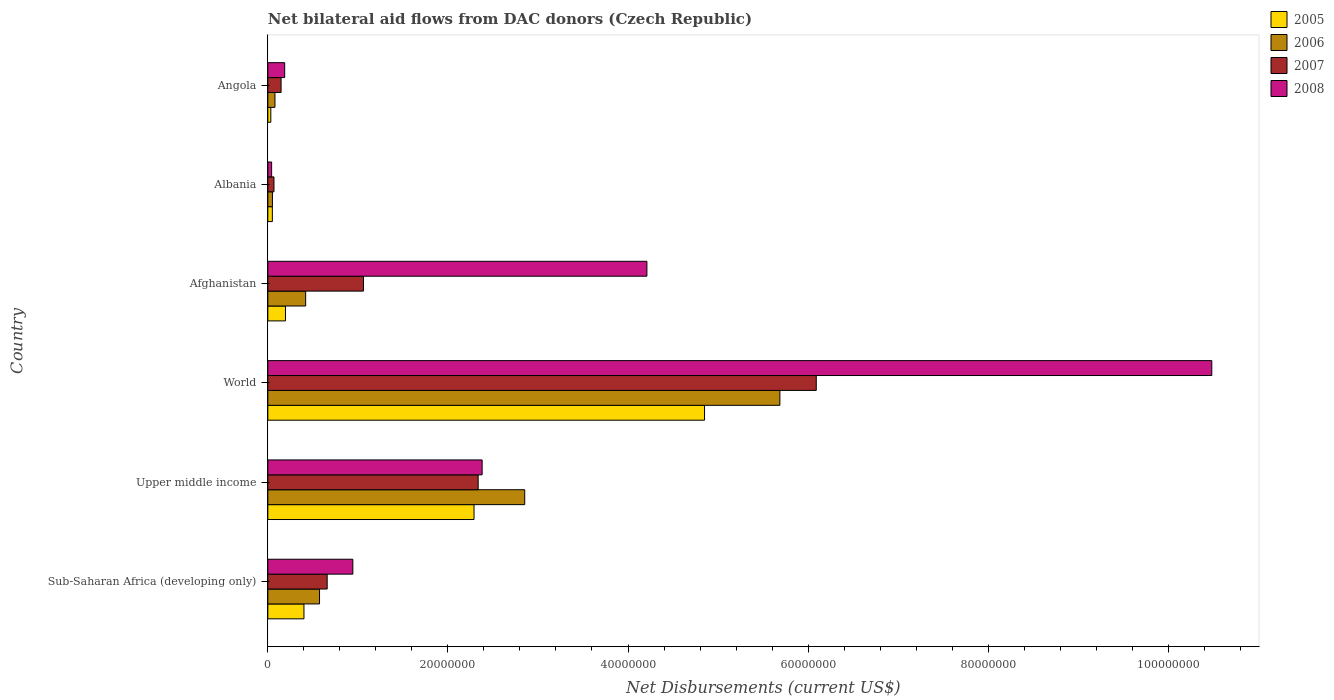How many groups of bars are there?
Ensure brevity in your answer.  6. Are the number of bars on each tick of the Y-axis equal?
Offer a very short reply. Yes. How many bars are there on the 2nd tick from the top?
Provide a short and direct response. 4. How many bars are there on the 3rd tick from the bottom?
Your answer should be very brief. 4. What is the label of the 5th group of bars from the top?
Offer a very short reply. Upper middle income. In how many cases, is the number of bars for a given country not equal to the number of legend labels?
Your answer should be very brief. 0. What is the net bilateral aid flows in 2007 in Upper middle income?
Your answer should be very brief. 2.34e+07. Across all countries, what is the maximum net bilateral aid flows in 2006?
Keep it short and to the point. 5.69e+07. In which country was the net bilateral aid flows in 2005 minimum?
Your response must be concise. Angola. What is the total net bilateral aid flows in 2005 in the graph?
Offer a very short reply. 7.82e+07. What is the difference between the net bilateral aid flows in 2005 in Afghanistan and that in World?
Give a very brief answer. -4.65e+07. What is the difference between the net bilateral aid flows in 2006 in Sub-Saharan Africa (developing only) and the net bilateral aid flows in 2008 in Upper middle income?
Provide a succinct answer. -1.81e+07. What is the average net bilateral aid flows in 2006 per country?
Provide a short and direct response. 1.61e+07. What is the difference between the net bilateral aid flows in 2005 and net bilateral aid flows in 2008 in World?
Ensure brevity in your answer.  -5.63e+07. What is the ratio of the net bilateral aid flows in 2007 in Sub-Saharan Africa (developing only) to that in World?
Keep it short and to the point. 0.11. What is the difference between the highest and the second highest net bilateral aid flows in 2007?
Your response must be concise. 3.76e+07. What is the difference between the highest and the lowest net bilateral aid flows in 2005?
Your answer should be compact. 4.82e+07. In how many countries, is the net bilateral aid flows in 2007 greater than the average net bilateral aid flows in 2007 taken over all countries?
Your response must be concise. 2. Is it the case that in every country, the sum of the net bilateral aid flows in 2008 and net bilateral aid flows in 2005 is greater than the net bilateral aid flows in 2006?
Provide a short and direct response. Yes. Does the graph contain any zero values?
Give a very brief answer. No. Does the graph contain grids?
Provide a succinct answer. No. Where does the legend appear in the graph?
Your response must be concise. Top right. What is the title of the graph?
Offer a very short reply. Net bilateral aid flows from DAC donors (Czech Republic). What is the label or title of the X-axis?
Your response must be concise. Net Disbursements (current US$). What is the Net Disbursements (current US$) in 2005 in Sub-Saharan Africa (developing only)?
Provide a succinct answer. 4.01e+06. What is the Net Disbursements (current US$) in 2006 in Sub-Saharan Africa (developing only)?
Give a very brief answer. 5.74e+06. What is the Net Disbursements (current US$) of 2007 in Sub-Saharan Africa (developing only)?
Your answer should be compact. 6.59e+06. What is the Net Disbursements (current US$) of 2008 in Sub-Saharan Africa (developing only)?
Make the answer very short. 9.44e+06. What is the Net Disbursements (current US$) of 2005 in Upper middle income?
Your answer should be compact. 2.29e+07. What is the Net Disbursements (current US$) in 2006 in Upper middle income?
Your response must be concise. 2.85e+07. What is the Net Disbursements (current US$) of 2007 in Upper middle income?
Make the answer very short. 2.34e+07. What is the Net Disbursements (current US$) in 2008 in Upper middle income?
Offer a very short reply. 2.38e+07. What is the Net Disbursements (current US$) in 2005 in World?
Keep it short and to the point. 4.85e+07. What is the Net Disbursements (current US$) in 2006 in World?
Keep it short and to the point. 5.69e+07. What is the Net Disbursements (current US$) of 2007 in World?
Offer a terse response. 6.09e+07. What is the Net Disbursements (current US$) of 2008 in World?
Offer a terse response. 1.05e+08. What is the Net Disbursements (current US$) in 2005 in Afghanistan?
Provide a short and direct response. 1.96e+06. What is the Net Disbursements (current US$) in 2006 in Afghanistan?
Keep it short and to the point. 4.20e+06. What is the Net Disbursements (current US$) in 2007 in Afghanistan?
Your response must be concise. 1.06e+07. What is the Net Disbursements (current US$) of 2008 in Afghanistan?
Offer a terse response. 4.21e+07. What is the Net Disbursements (current US$) of 2005 in Albania?
Your response must be concise. 5.00e+05. What is the Net Disbursements (current US$) of 2006 in Albania?
Offer a very short reply. 5.10e+05. What is the Net Disbursements (current US$) of 2007 in Albania?
Ensure brevity in your answer.  6.80e+05. What is the Net Disbursements (current US$) in 2008 in Albania?
Offer a very short reply. 4.20e+05. What is the Net Disbursements (current US$) of 2005 in Angola?
Make the answer very short. 3.30e+05. What is the Net Disbursements (current US$) of 2006 in Angola?
Your answer should be compact. 7.90e+05. What is the Net Disbursements (current US$) in 2007 in Angola?
Provide a short and direct response. 1.47e+06. What is the Net Disbursements (current US$) of 2008 in Angola?
Keep it short and to the point. 1.87e+06. Across all countries, what is the maximum Net Disbursements (current US$) in 2005?
Provide a succinct answer. 4.85e+07. Across all countries, what is the maximum Net Disbursements (current US$) of 2006?
Provide a succinct answer. 5.69e+07. Across all countries, what is the maximum Net Disbursements (current US$) of 2007?
Ensure brevity in your answer.  6.09e+07. Across all countries, what is the maximum Net Disbursements (current US$) of 2008?
Your answer should be compact. 1.05e+08. Across all countries, what is the minimum Net Disbursements (current US$) in 2006?
Provide a succinct answer. 5.10e+05. Across all countries, what is the minimum Net Disbursements (current US$) of 2007?
Your answer should be compact. 6.80e+05. What is the total Net Disbursements (current US$) in 2005 in the graph?
Provide a succinct answer. 7.82e+07. What is the total Net Disbursements (current US$) of 2006 in the graph?
Give a very brief answer. 9.66e+07. What is the total Net Disbursements (current US$) in 2007 in the graph?
Offer a terse response. 1.04e+08. What is the total Net Disbursements (current US$) of 2008 in the graph?
Give a very brief answer. 1.82e+08. What is the difference between the Net Disbursements (current US$) in 2005 in Sub-Saharan Africa (developing only) and that in Upper middle income?
Your answer should be compact. -1.89e+07. What is the difference between the Net Disbursements (current US$) of 2006 in Sub-Saharan Africa (developing only) and that in Upper middle income?
Offer a very short reply. -2.28e+07. What is the difference between the Net Disbursements (current US$) of 2007 in Sub-Saharan Africa (developing only) and that in Upper middle income?
Give a very brief answer. -1.68e+07. What is the difference between the Net Disbursements (current US$) of 2008 in Sub-Saharan Africa (developing only) and that in Upper middle income?
Give a very brief answer. -1.44e+07. What is the difference between the Net Disbursements (current US$) in 2005 in Sub-Saharan Africa (developing only) and that in World?
Your answer should be very brief. -4.45e+07. What is the difference between the Net Disbursements (current US$) in 2006 in Sub-Saharan Africa (developing only) and that in World?
Give a very brief answer. -5.11e+07. What is the difference between the Net Disbursements (current US$) in 2007 in Sub-Saharan Africa (developing only) and that in World?
Your answer should be compact. -5.43e+07. What is the difference between the Net Disbursements (current US$) of 2008 in Sub-Saharan Africa (developing only) and that in World?
Your answer should be very brief. -9.54e+07. What is the difference between the Net Disbursements (current US$) of 2005 in Sub-Saharan Africa (developing only) and that in Afghanistan?
Provide a short and direct response. 2.05e+06. What is the difference between the Net Disbursements (current US$) in 2006 in Sub-Saharan Africa (developing only) and that in Afghanistan?
Provide a short and direct response. 1.54e+06. What is the difference between the Net Disbursements (current US$) of 2007 in Sub-Saharan Africa (developing only) and that in Afghanistan?
Provide a short and direct response. -4.03e+06. What is the difference between the Net Disbursements (current US$) of 2008 in Sub-Saharan Africa (developing only) and that in Afghanistan?
Your answer should be very brief. -3.27e+07. What is the difference between the Net Disbursements (current US$) of 2005 in Sub-Saharan Africa (developing only) and that in Albania?
Keep it short and to the point. 3.51e+06. What is the difference between the Net Disbursements (current US$) in 2006 in Sub-Saharan Africa (developing only) and that in Albania?
Provide a short and direct response. 5.23e+06. What is the difference between the Net Disbursements (current US$) of 2007 in Sub-Saharan Africa (developing only) and that in Albania?
Provide a succinct answer. 5.91e+06. What is the difference between the Net Disbursements (current US$) of 2008 in Sub-Saharan Africa (developing only) and that in Albania?
Keep it short and to the point. 9.02e+06. What is the difference between the Net Disbursements (current US$) of 2005 in Sub-Saharan Africa (developing only) and that in Angola?
Your answer should be very brief. 3.68e+06. What is the difference between the Net Disbursements (current US$) of 2006 in Sub-Saharan Africa (developing only) and that in Angola?
Give a very brief answer. 4.95e+06. What is the difference between the Net Disbursements (current US$) in 2007 in Sub-Saharan Africa (developing only) and that in Angola?
Your answer should be very brief. 5.12e+06. What is the difference between the Net Disbursements (current US$) in 2008 in Sub-Saharan Africa (developing only) and that in Angola?
Your answer should be very brief. 7.57e+06. What is the difference between the Net Disbursements (current US$) in 2005 in Upper middle income and that in World?
Provide a succinct answer. -2.56e+07. What is the difference between the Net Disbursements (current US$) of 2006 in Upper middle income and that in World?
Your answer should be compact. -2.83e+07. What is the difference between the Net Disbursements (current US$) of 2007 in Upper middle income and that in World?
Provide a succinct answer. -3.76e+07. What is the difference between the Net Disbursements (current US$) in 2008 in Upper middle income and that in World?
Offer a terse response. -8.10e+07. What is the difference between the Net Disbursements (current US$) of 2005 in Upper middle income and that in Afghanistan?
Ensure brevity in your answer.  2.09e+07. What is the difference between the Net Disbursements (current US$) of 2006 in Upper middle income and that in Afghanistan?
Your answer should be very brief. 2.43e+07. What is the difference between the Net Disbursements (current US$) of 2007 in Upper middle income and that in Afghanistan?
Offer a terse response. 1.27e+07. What is the difference between the Net Disbursements (current US$) of 2008 in Upper middle income and that in Afghanistan?
Provide a short and direct response. -1.83e+07. What is the difference between the Net Disbursements (current US$) in 2005 in Upper middle income and that in Albania?
Make the answer very short. 2.24e+07. What is the difference between the Net Disbursements (current US$) of 2006 in Upper middle income and that in Albania?
Give a very brief answer. 2.80e+07. What is the difference between the Net Disbursements (current US$) in 2007 in Upper middle income and that in Albania?
Offer a very short reply. 2.27e+07. What is the difference between the Net Disbursements (current US$) in 2008 in Upper middle income and that in Albania?
Provide a succinct answer. 2.34e+07. What is the difference between the Net Disbursements (current US$) of 2005 in Upper middle income and that in Angola?
Your response must be concise. 2.26e+07. What is the difference between the Net Disbursements (current US$) of 2006 in Upper middle income and that in Angola?
Keep it short and to the point. 2.77e+07. What is the difference between the Net Disbursements (current US$) of 2007 in Upper middle income and that in Angola?
Give a very brief answer. 2.19e+07. What is the difference between the Net Disbursements (current US$) in 2008 in Upper middle income and that in Angola?
Provide a short and direct response. 2.19e+07. What is the difference between the Net Disbursements (current US$) in 2005 in World and that in Afghanistan?
Your answer should be very brief. 4.65e+07. What is the difference between the Net Disbursements (current US$) of 2006 in World and that in Afghanistan?
Provide a succinct answer. 5.27e+07. What is the difference between the Net Disbursements (current US$) in 2007 in World and that in Afghanistan?
Provide a succinct answer. 5.03e+07. What is the difference between the Net Disbursements (current US$) in 2008 in World and that in Afghanistan?
Provide a short and direct response. 6.27e+07. What is the difference between the Net Disbursements (current US$) in 2005 in World and that in Albania?
Keep it short and to the point. 4.80e+07. What is the difference between the Net Disbursements (current US$) in 2006 in World and that in Albania?
Your answer should be compact. 5.64e+07. What is the difference between the Net Disbursements (current US$) in 2007 in World and that in Albania?
Keep it short and to the point. 6.02e+07. What is the difference between the Net Disbursements (current US$) of 2008 in World and that in Albania?
Your answer should be very brief. 1.04e+08. What is the difference between the Net Disbursements (current US$) of 2005 in World and that in Angola?
Your answer should be very brief. 4.82e+07. What is the difference between the Net Disbursements (current US$) of 2006 in World and that in Angola?
Ensure brevity in your answer.  5.61e+07. What is the difference between the Net Disbursements (current US$) of 2007 in World and that in Angola?
Make the answer very short. 5.94e+07. What is the difference between the Net Disbursements (current US$) of 2008 in World and that in Angola?
Give a very brief answer. 1.03e+08. What is the difference between the Net Disbursements (current US$) in 2005 in Afghanistan and that in Albania?
Your answer should be very brief. 1.46e+06. What is the difference between the Net Disbursements (current US$) of 2006 in Afghanistan and that in Albania?
Offer a very short reply. 3.69e+06. What is the difference between the Net Disbursements (current US$) in 2007 in Afghanistan and that in Albania?
Keep it short and to the point. 9.94e+06. What is the difference between the Net Disbursements (current US$) of 2008 in Afghanistan and that in Albania?
Offer a terse response. 4.17e+07. What is the difference between the Net Disbursements (current US$) of 2005 in Afghanistan and that in Angola?
Your answer should be very brief. 1.63e+06. What is the difference between the Net Disbursements (current US$) in 2006 in Afghanistan and that in Angola?
Offer a terse response. 3.41e+06. What is the difference between the Net Disbursements (current US$) of 2007 in Afghanistan and that in Angola?
Provide a short and direct response. 9.15e+06. What is the difference between the Net Disbursements (current US$) of 2008 in Afghanistan and that in Angola?
Ensure brevity in your answer.  4.02e+07. What is the difference between the Net Disbursements (current US$) in 2006 in Albania and that in Angola?
Provide a short and direct response. -2.80e+05. What is the difference between the Net Disbursements (current US$) in 2007 in Albania and that in Angola?
Provide a succinct answer. -7.90e+05. What is the difference between the Net Disbursements (current US$) of 2008 in Albania and that in Angola?
Your answer should be very brief. -1.45e+06. What is the difference between the Net Disbursements (current US$) in 2005 in Sub-Saharan Africa (developing only) and the Net Disbursements (current US$) in 2006 in Upper middle income?
Give a very brief answer. -2.45e+07. What is the difference between the Net Disbursements (current US$) of 2005 in Sub-Saharan Africa (developing only) and the Net Disbursements (current US$) of 2007 in Upper middle income?
Provide a succinct answer. -1.94e+07. What is the difference between the Net Disbursements (current US$) in 2005 in Sub-Saharan Africa (developing only) and the Net Disbursements (current US$) in 2008 in Upper middle income?
Your response must be concise. -1.98e+07. What is the difference between the Net Disbursements (current US$) of 2006 in Sub-Saharan Africa (developing only) and the Net Disbursements (current US$) of 2007 in Upper middle income?
Provide a succinct answer. -1.76e+07. What is the difference between the Net Disbursements (current US$) of 2006 in Sub-Saharan Africa (developing only) and the Net Disbursements (current US$) of 2008 in Upper middle income?
Your answer should be very brief. -1.81e+07. What is the difference between the Net Disbursements (current US$) in 2007 in Sub-Saharan Africa (developing only) and the Net Disbursements (current US$) in 2008 in Upper middle income?
Ensure brevity in your answer.  -1.72e+07. What is the difference between the Net Disbursements (current US$) of 2005 in Sub-Saharan Africa (developing only) and the Net Disbursements (current US$) of 2006 in World?
Your answer should be compact. -5.29e+07. What is the difference between the Net Disbursements (current US$) of 2005 in Sub-Saharan Africa (developing only) and the Net Disbursements (current US$) of 2007 in World?
Provide a short and direct response. -5.69e+07. What is the difference between the Net Disbursements (current US$) of 2005 in Sub-Saharan Africa (developing only) and the Net Disbursements (current US$) of 2008 in World?
Offer a terse response. -1.01e+08. What is the difference between the Net Disbursements (current US$) of 2006 in Sub-Saharan Africa (developing only) and the Net Disbursements (current US$) of 2007 in World?
Make the answer very short. -5.52e+07. What is the difference between the Net Disbursements (current US$) in 2006 in Sub-Saharan Africa (developing only) and the Net Disbursements (current US$) in 2008 in World?
Provide a succinct answer. -9.91e+07. What is the difference between the Net Disbursements (current US$) in 2007 in Sub-Saharan Africa (developing only) and the Net Disbursements (current US$) in 2008 in World?
Make the answer very short. -9.82e+07. What is the difference between the Net Disbursements (current US$) in 2005 in Sub-Saharan Africa (developing only) and the Net Disbursements (current US$) in 2007 in Afghanistan?
Ensure brevity in your answer.  -6.61e+06. What is the difference between the Net Disbursements (current US$) of 2005 in Sub-Saharan Africa (developing only) and the Net Disbursements (current US$) of 2008 in Afghanistan?
Ensure brevity in your answer.  -3.81e+07. What is the difference between the Net Disbursements (current US$) of 2006 in Sub-Saharan Africa (developing only) and the Net Disbursements (current US$) of 2007 in Afghanistan?
Offer a terse response. -4.88e+06. What is the difference between the Net Disbursements (current US$) in 2006 in Sub-Saharan Africa (developing only) and the Net Disbursements (current US$) in 2008 in Afghanistan?
Make the answer very short. -3.64e+07. What is the difference between the Net Disbursements (current US$) of 2007 in Sub-Saharan Africa (developing only) and the Net Disbursements (current US$) of 2008 in Afghanistan?
Your answer should be compact. -3.55e+07. What is the difference between the Net Disbursements (current US$) of 2005 in Sub-Saharan Africa (developing only) and the Net Disbursements (current US$) of 2006 in Albania?
Offer a terse response. 3.50e+06. What is the difference between the Net Disbursements (current US$) of 2005 in Sub-Saharan Africa (developing only) and the Net Disbursements (current US$) of 2007 in Albania?
Ensure brevity in your answer.  3.33e+06. What is the difference between the Net Disbursements (current US$) of 2005 in Sub-Saharan Africa (developing only) and the Net Disbursements (current US$) of 2008 in Albania?
Your answer should be compact. 3.59e+06. What is the difference between the Net Disbursements (current US$) of 2006 in Sub-Saharan Africa (developing only) and the Net Disbursements (current US$) of 2007 in Albania?
Make the answer very short. 5.06e+06. What is the difference between the Net Disbursements (current US$) of 2006 in Sub-Saharan Africa (developing only) and the Net Disbursements (current US$) of 2008 in Albania?
Ensure brevity in your answer.  5.32e+06. What is the difference between the Net Disbursements (current US$) in 2007 in Sub-Saharan Africa (developing only) and the Net Disbursements (current US$) in 2008 in Albania?
Make the answer very short. 6.17e+06. What is the difference between the Net Disbursements (current US$) in 2005 in Sub-Saharan Africa (developing only) and the Net Disbursements (current US$) in 2006 in Angola?
Your answer should be very brief. 3.22e+06. What is the difference between the Net Disbursements (current US$) in 2005 in Sub-Saharan Africa (developing only) and the Net Disbursements (current US$) in 2007 in Angola?
Your answer should be compact. 2.54e+06. What is the difference between the Net Disbursements (current US$) of 2005 in Sub-Saharan Africa (developing only) and the Net Disbursements (current US$) of 2008 in Angola?
Your response must be concise. 2.14e+06. What is the difference between the Net Disbursements (current US$) in 2006 in Sub-Saharan Africa (developing only) and the Net Disbursements (current US$) in 2007 in Angola?
Give a very brief answer. 4.27e+06. What is the difference between the Net Disbursements (current US$) of 2006 in Sub-Saharan Africa (developing only) and the Net Disbursements (current US$) of 2008 in Angola?
Keep it short and to the point. 3.87e+06. What is the difference between the Net Disbursements (current US$) of 2007 in Sub-Saharan Africa (developing only) and the Net Disbursements (current US$) of 2008 in Angola?
Your answer should be very brief. 4.72e+06. What is the difference between the Net Disbursements (current US$) in 2005 in Upper middle income and the Net Disbursements (current US$) in 2006 in World?
Provide a succinct answer. -3.40e+07. What is the difference between the Net Disbursements (current US$) in 2005 in Upper middle income and the Net Disbursements (current US$) in 2007 in World?
Your answer should be compact. -3.80e+07. What is the difference between the Net Disbursements (current US$) of 2005 in Upper middle income and the Net Disbursements (current US$) of 2008 in World?
Make the answer very short. -8.19e+07. What is the difference between the Net Disbursements (current US$) in 2006 in Upper middle income and the Net Disbursements (current US$) in 2007 in World?
Offer a very short reply. -3.24e+07. What is the difference between the Net Disbursements (current US$) of 2006 in Upper middle income and the Net Disbursements (current US$) of 2008 in World?
Keep it short and to the point. -7.63e+07. What is the difference between the Net Disbursements (current US$) in 2007 in Upper middle income and the Net Disbursements (current US$) in 2008 in World?
Give a very brief answer. -8.15e+07. What is the difference between the Net Disbursements (current US$) of 2005 in Upper middle income and the Net Disbursements (current US$) of 2006 in Afghanistan?
Your response must be concise. 1.87e+07. What is the difference between the Net Disbursements (current US$) of 2005 in Upper middle income and the Net Disbursements (current US$) of 2007 in Afghanistan?
Make the answer very short. 1.23e+07. What is the difference between the Net Disbursements (current US$) of 2005 in Upper middle income and the Net Disbursements (current US$) of 2008 in Afghanistan?
Provide a short and direct response. -1.92e+07. What is the difference between the Net Disbursements (current US$) in 2006 in Upper middle income and the Net Disbursements (current US$) in 2007 in Afghanistan?
Ensure brevity in your answer.  1.79e+07. What is the difference between the Net Disbursements (current US$) in 2006 in Upper middle income and the Net Disbursements (current US$) in 2008 in Afghanistan?
Provide a short and direct response. -1.36e+07. What is the difference between the Net Disbursements (current US$) of 2007 in Upper middle income and the Net Disbursements (current US$) of 2008 in Afghanistan?
Provide a succinct answer. -1.87e+07. What is the difference between the Net Disbursements (current US$) of 2005 in Upper middle income and the Net Disbursements (current US$) of 2006 in Albania?
Your response must be concise. 2.24e+07. What is the difference between the Net Disbursements (current US$) in 2005 in Upper middle income and the Net Disbursements (current US$) in 2007 in Albania?
Offer a terse response. 2.22e+07. What is the difference between the Net Disbursements (current US$) of 2005 in Upper middle income and the Net Disbursements (current US$) of 2008 in Albania?
Offer a terse response. 2.25e+07. What is the difference between the Net Disbursements (current US$) in 2006 in Upper middle income and the Net Disbursements (current US$) in 2007 in Albania?
Your answer should be very brief. 2.78e+07. What is the difference between the Net Disbursements (current US$) in 2006 in Upper middle income and the Net Disbursements (current US$) in 2008 in Albania?
Offer a terse response. 2.81e+07. What is the difference between the Net Disbursements (current US$) of 2007 in Upper middle income and the Net Disbursements (current US$) of 2008 in Albania?
Provide a short and direct response. 2.29e+07. What is the difference between the Net Disbursements (current US$) of 2005 in Upper middle income and the Net Disbursements (current US$) of 2006 in Angola?
Your response must be concise. 2.21e+07. What is the difference between the Net Disbursements (current US$) of 2005 in Upper middle income and the Net Disbursements (current US$) of 2007 in Angola?
Offer a very short reply. 2.14e+07. What is the difference between the Net Disbursements (current US$) in 2005 in Upper middle income and the Net Disbursements (current US$) in 2008 in Angola?
Your answer should be very brief. 2.10e+07. What is the difference between the Net Disbursements (current US$) of 2006 in Upper middle income and the Net Disbursements (current US$) of 2007 in Angola?
Ensure brevity in your answer.  2.71e+07. What is the difference between the Net Disbursements (current US$) of 2006 in Upper middle income and the Net Disbursements (current US$) of 2008 in Angola?
Your response must be concise. 2.67e+07. What is the difference between the Net Disbursements (current US$) of 2007 in Upper middle income and the Net Disbursements (current US$) of 2008 in Angola?
Provide a succinct answer. 2.15e+07. What is the difference between the Net Disbursements (current US$) in 2005 in World and the Net Disbursements (current US$) in 2006 in Afghanistan?
Offer a very short reply. 4.43e+07. What is the difference between the Net Disbursements (current US$) in 2005 in World and the Net Disbursements (current US$) in 2007 in Afghanistan?
Your response must be concise. 3.79e+07. What is the difference between the Net Disbursements (current US$) in 2005 in World and the Net Disbursements (current US$) in 2008 in Afghanistan?
Ensure brevity in your answer.  6.40e+06. What is the difference between the Net Disbursements (current US$) of 2006 in World and the Net Disbursements (current US$) of 2007 in Afghanistan?
Make the answer very short. 4.62e+07. What is the difference between the Net Disbursements (current US$) in 2006 in World and the Net Disbursements (current US$) in 2008 in Afghanistan?
Provide a succinct answer. 1.48e+07. What is the difference between the Net Disbursements (current US$) of 2007 in World and the Net Disbursements (current US$) of 2008 in Afghanistan?
Keep it short and to the point. 1.88e+07. What is the difference between the Net Disbursements (current US$) in 2005 in World and the Net Disbursements (current US$) in 2006 in Albania?
Keep it short and to the point. 4.80e+07. What is the difference between the Net Disbursements (current US$) of 2005 in World and the Net Disbursements (current US$) of 2007 in Albania?
Offer a terse response. 4.78e+07. What is the difference between the Net Disbursements (current US$) of 2005 in World and the Net Disbursements (current US$) of 2008 in Albania?
Offer a terse response. 4.81e+07. What is the difference between the Net Disbursements (current US$) of 2006 in World and the Net Disbursements (current US$) of 2007 in Albania?
Make the answer very short. 5.62e+07. What is the difference between the Net Disbursements (current US$) in 2006 in World and the Net Disbursements (current US$) in 2008 in Albania?
Provide a short and direct response. 5.64e+07. What is the difference between the Net Disbursements (current US$) in 2007 in World and the Net Disbursements (current US$) in 2008 in Albania?
Your answer should be compact. 6.05e+07. What is the difference between the Net Disbursements (current US$) of 2005 in World and the Net Disbursements (current US$) of 2006 in Angola?
Ensure brevity in your answer.  4.77e+07. What is the difference between the Net Disbursements (current US$) of 2005 in World and the Net Disbursements (current US$) of 2007 in Angola?
Your response must be concise. 4.70e+07. What is the difference between the Net Disbursements (current US$) of 2005 in World and the Net Disbursements (current US$) of 2008 in Angola?
Keep it short and to the point. 4.66e+07. What is the difference between the Net Disbursements (current US$) of 2006 in World and the Net Disbursements (current US$) of 2007 in Angola?
Provide a short and direct response. 5.54e+07. What is the difference between the Net Disbursements (current US$) in 2006 in World and the Net Disbursements (current US$) in 2008 in Angola?
Provide a short and direct response. 5.50e+07. What is the difference between the Net Disbursements (current US$) of 2007 in World and the Net Disbursements (current US$) of 2008 in Angola?
Provide a succinct answer. 5.90e+07. What is the difference between the Net Disbursements (current US$) of 2005 in Afghanistan and the Net Disbursements (current US$) of 2006 in Albania?
Offer a terse response. 1.45e+06. What is the difference between the Net Disbursements (current US$) of 2005 in Afghanistan and the Net Disbursements (current US$) of 2007 in Albania?
Provide a succinct answer. 1.28e+06. What is the difference between the Net Disbursements (current US$) in 2005 in Afghanistan and the Net Disbursements (current US$) in 2008 in Albania?
Keep it short and to the point. 1.54e+06. What is the difference between the Net Disbursements (current US$) of 2006 in Afghanistan and the Net Disbursements (current US$) of 2007 in Albania?
Ensure brevity in your answer.  3.52e+06. What is the difference between the Net Disbursements (current US$) in 2006 in Afghanistan and the Net Disbursements (current US$) in 2008 in Albania?
Provide a short and direct response. 3.78e+06. What is the difference between the Net Disbursements (current US$) in 2007 in Afghanistan and the Net Disbursements (current US$) in 2008 in Albania?
Your answer should be compact. 1.02e+07. What is the difference between the Net Disbursements (current US$) of 2005 in Afghanistan and the Net Disbursements (current US$) of 2006 in Angola?
Your answer should be compact. 1.17e+06. What is the difference between the Net Disbursements (current US$) in 2006 in Afghanistan and the Net Disbursements (current US$) in 2007 in Angola?
Your answer should be compact. 2.73e+06. What is the difference between the Net Disbursements (current US$) in 2006 in Afghanistan and the Net Disbursements (current US$) in 2008 in Angola?
Provide a short and direct response. 2.33e+06. What is the difference between the Net Disbursements (current US$) of 2007 in Afghanistan and the Net Disbursements (current US$) of 2008 in Angola?
Your answer should be compact. 8.75e+06. What is the difference between the Net Disbursements (current US$) of 2005 in Albania and the Net Disbursements (current US$) of 2007 in Angola?
Give a very brief answer. -9.70e+05. What is the difference between the Net Disbursements (current US$) of 2005 in Albania and the Net Disbursements (current US$) of 2008 in Angola?
Give a very brief answer. -1.37e+06. What is the difference between the Net Disbursements (current US$) in 2006 in Albania and the Net Disbursements (current US$) in 2007 in Angola?
Your response must be concise. -9.60e+05. What is the difference between the Net Disbursements (current US$) of 2006 in Albania and the Net Disbursements (current US$) of 2008 in Angola?
Provide a succinct answer. -1.36e+06. What is the difference between the Net Disbursements (current US$) of 2007 in Albania and the Net Disbursements (current US$) of 2008 in Angola?
Ensure brevity in your answer.  -1.19e+06. What is the average Net Disbursements (current US$) of 2005 per country?
Provide a short and direct response. 1.30e+07. What is the average Net Disbursements (current US$) in 2006 per country?
Provide a succinct answer. 1.61e+07. What is the average Net Disbursements (current US$) of 2007 per country?
Give a very brief answer. 1.73e+07. What is the average Net Disbursements (current US$) of 2008 per country?
Your answer should be very brief. 3.04e+07. What is the difference between the Net Disbursements (current US$) of 2005 and Net Disbursements (current US$) of 2006 in Sub-Saharan Africa (developing only)?
Make the answer very short. -1.73e+06. What is the difference between the Net Disbursements (current US$) of 2005 and Net Disbursements (current US$) of 2007 in Sub-Saharan Africa (developing only)?
Provide a succinct answer. -2.58e+06. What is the difference between the Net Disbursements (current US$) in 2005 and Net Disbursements (current US$) in 2008 in Sub-Saharan Africa (developing only)?
Offer a terse response. -5.43e+06. What is the difference between the Net Disbursements (current US$) in 2006 and Net Disbursements (current US$) in 2007 in Sub-Saharan Africa (developing only)?
Give a very brief answer. -8.50e+05. What is the difference between the Net Disbursements (current US$) in 2006 and Net Disbursements (current US$) in 2008 in Sub-Saharan Africa (developing only)?
Provide a short and direct response. -3.70e+06. What is the difference between the Net Disbursements (current US$) in 2007 and Net Disbursements (current US$) in 2008 in Sub-Saharan Africa (developing only)?
Ensure brevity in your answer.  -2.85e+06. What is the difference between the Net Disbursements (current US$) in 2005 and Net Disbursements (current US$) in 2006 in Upper middle income?
Your answer should be compact. -5.63e+06. What is the difference between the Net Disbursements (current US$) of 2005 and Net Disbursements (current US$) of 2007 in Upper middle income?
Make the answer very short. -4.60e+05. What is the difference between the Net Disbursements (current US$) of 2005 and Net Disbursements (current US$) of 2008 in Upper middle income?
Keep it short and to the point. -9.00e+05. What is the difference between the Net Disbursements (current US$) of 2006 and Net Disbursements (current US$) of 2007 in Upper middle income?
Offer a terse response. 5.17e+06. What is the difference between the Net Disbursements (current US$) in 2006 and Net Disbursements (current US$) in 2008 in Upper middle income?
Provide a succinct answer. 4.73e+06. What is the difference between the Net Disbursements (current US$) of 2007 and Net Disbursements (current US$) of 2008 in Upper middle income?
Make the answer very short. -4.40e+05. What is the difference between the Net Disbursements (current US$) of 2005 and Net Disbursements (current US$) of 2006 in World?
Provide a short and direct response. -8.37e+06. What is the difference between the Net Disbursements (current US$) in 2005 and Net Disbursements (current US$) in 2007 in World?
Your response must be concise. -1.24e+07. What is the difference between the Net Disbursements (current US$) in 2005 and Net Disbursements (current US$) in 2008 in World?
Offer a terse response. -5.63e+07. What is the difference between the Net Disbursements (current US$) in 2006 and Net Disbursements (current US$) in 2007 in World?
Offer a terse response. -4.04e+06. What is the difference between the Net Disbursements (current US$) of 2006 and Net Disbursements (current US$) of 2008 in World?
Make the answer very short. -4.80e+07. What is the difference between the Net Disbursements (current US$) in 2007 and Net Disbursements (current US$) in 2008 in World?
Provide a succinct answer. -4.39e+07. What is the difference between the Net Disbursements (current US$) in 2005 and Net Disbursements (current US$) in 2006 in Afghanistan?
Provide a succinct answer. -2.24e+06. What is the difference between the Net Disbursements (current US$) of 2005 and Net Disbursements (current US$) of 2007 in Afghanistan?
Your answer should be compact. -8.66e+06. What is the difference between the Net Disbursements (current US$) in 2005 and Net Disbursements (current US$) in 2008 in Afghanistan?
Provide a short and direct response. -4.01e+07. What is the difference between the Net Disbursements (current US$) in 2006 and Net Disbursements (current US$) in 2007 in Afghanistan?
Your response must be concise. -6.42e+06. What is the difference between the Net Disbursements (current US$) in 2006 and Net Disbursements (current US$) in 2008 in Afghanistan?
Your answer should be compact. -3.79e+07. What is the difference between the Net Disbursements (current US$) of 2007 and Net Disbursements (current US$) of 2008 in Afghanistan?
Offer a very short reply. -3.15e+07. What is the difference between the Net Disbursements (current US$) in 2005 and Net Disbursements (current US$) in 2008 in Albania?
Your response must be concise. 8.00e+04. What is the difference between the Net Disbursements (current US$) in 2006 and Net Disbursements (current US$) in 2007 in Albania?
Your answer should be very brief. -1.70e+05. What is the difference between the Net Disbursements (current US$) in 2005 and Net Disbursements (current US$) in 2006 in Angola?
Keep it short and to the point. -4.60e+05. What is the difference between the Net Disbursements (current US$) of 2005 and Net Disbursements (current US$) of 2007 in Angola?
Ensure brevity in your answer.  -1.14e+06. What is the difference between the Net Disbursements (current US$) of 2005 and Net Disbursements (current US$) of 2008 in Angola?
Provide a succinct answer. -1.54e+06. What is the difference between the Net Disbursements (current US$) in 2006 and Net Disbursements (current US$) in 2007 in Angola?
Keep it short and to the point. -6.80e+05. What is the difference between the Net Disbursements (current US$) of 2006 and Net Disbursements (current US$) of 2008 in Angola?
Your response must be concise. -1.08e+06. What is the difference between the Net Disbursements (current US$) of 2007 and Net Disbursements (current US$) of 2008 in Angola?
Your answer should be very brief. -4.00e+05. What is the ratio of the Net Disbursements (current US$) in 2005 in Sub-Saharan Africa (developing only) to that in Upper middle income?
Your response must be concise. 0.18. What is the ratio of the Net Disbursements (current US$) in 2006 in Sub-Saharan Africa (developing only) to that in Upper middle income?
Keep it short and to the point. 0.2. What is the ratio of the Net Disbursements (current US$) of 2007 in Sub-Saharan Africa (developing only) to that in Upper middle income?
Your answer should be compact. 0.28. What is the ratio of the Net Disbursements (current US$) of 2008 in Sub-Saharan Africa (developing only) to that in Upper middle income?
Offer a very short reply. 0.4. What is the ratio of the Net Disbursements (current US$) of 2005 in Sub-Saharan Africa (developing only) to that in World?
Make the answer very short. 0.08. What is the ratio of the Net Disbursements (current US$) in 2006 in Sub-Saharan Africa (developing only) to that in World?
Offer a very short reply. 0.1. What is the ratio of the Net Disbursements (current US$) in 2007 in Sub-Saharan Africa (developing only) to that in World?
Give a very brief answer. 0.11. What is the ratio of the Net Disbursements (current US$) in 2008 in Sub-Saharan Africa (developing only) to that in World?
Provide a succinct answer. 0.09. What is the ratio of the Net Disbursements (current US$) of 2005 in Sub-Saharan Africa (developing only) to that in Afghanistan?
Offer a very short reply. 2.05. What is the ratio of the Net Disbursements (current US$) in 2006 in Sub-Saharan Africa (developing only) to that in Afghanistan?
Offer a very short reply. 1.37. What is the ratio of the Net Disbursements (current US$) in 2007 in Sub-Saharan Africa (developing only) to that in Afghanistan?
Provide a short and direct response. 0.62. What is the ratio of the Net Disbursements (current US$) of 2008 in Sub-Saharan Africa (developing only) to that in Afghanistan?
Provide a succinct answer. 0.22. What is the ratio of the Net Disbursements (current US$) in 2005 in Sub-Saharan Africa (developing only) to that in Albania?
Make the answer very short. 8.02. What is the ratio of the Net Disbursements (current US$) in 2006 in Sub-Saharan Africa (developing only) to that in Albania?
Provide a short and direct response. 11.25. What is the ratio of the Net Disbursements (current US$) in 2007 in Sub-Saharan Africa (developing only) to that in Albania?
Offer a very short reply. 9.69. What is the ratio of the Net Disbursements (current US$) in 2008 in Sub-Saharan Africa (developing only) to that in Albania?
Provide a short and direct response. 22.48. What is the ratio of the Net Disbursements (current US$) in 2005 in Sub-Saharan Africa (developing only) to that in Angola?
Offer a terse response. 12.15. What is the ratio of the Net Disbursements (current US$) of 2006 in Sub-Saharan Africa (developing only) to that in Angola?
Keep it short and to the point. 7.27. What is the ratio of the Net Disbursements (current US$) in 2007 in Sub-Saharan Africa (developing only) to that in Angola?
Offer a very short reply. 4.48. What is the ratio of the Net Disbursements (current US$) in 2008 in Sub-Saharan Africa (developing only) to that in Angola?
Make the answer very short. 5.05. What is the ratio of the Net Disbursements (current US$) in 2005 in Upper middle income to that in World?
Give a very brief answer. 0.47. What is the ratio of the Net Disbursements (current US$) in 2006 in Upper middle income to that in World?
Your answer should be compact. 0.5. What is the ratio of the Net Disbursements (current US$) in 2007 in Upper middle income to that in World?
Provide a short and direct response. 0.38. What is the ratio of the Net Disbursements (current US$) of 2008 in Upper middle income to that in World?
Make the answer very short. 0.23. What is the ratio of the Net Disbursements (current US$) in 2005 in Upper middle income to that in Afghanistan?
Ensure brevity in your answer.  11.68. What is the ratio of the Net Disbursements (current US$) in 2006 in Upper middle income to that in Afghanistan?
Your answer should be very brief. 6.79. What is the ratio of the Net Disbursements (current US$) in 2007 in Upper middle income to that in Afghanistan?
Provide a succinct answer. 2.2. What is the ratio of the Net Disbursements (current US$) of 2008 in Upper middle income to that in Afghanistan?
Offer a terse response. 0.57. What is the ratio of the Net Disbursements (current US$) in 2005 in Upper middle income to that in Albania?
Your answer should be compact. 45.8. What is the ratio of the Net Disbursements (current US$) in 2006 in Upper middle income to that in Albania?
Keep it short and to the point. 55.94. What is the ratio of the Net Disbursements (current US$) of 2007 in Upper middle income to that in Albania?
Ensure brevity in your answer.  34.35. What is the ratio of the Net Disbursements (current US$) of 2008 in Upper middle income to that in Albania?
Your answer should be compact. 56.67. What is the ratio of the Net Disbursements (current US$) of 2005 in Upper middle income to that in Angola?
Your answer should be compact. 69.39. What is the ratio of the Net Disbursements (current US$) in 2006 in Upper middle income to that in Angola?
Offer a terse response. 36.11. What is the ratio of the Net Disbursements (current US$) in 2007 in Upper middle income to that in Angola?
Offer a very short reply. 15.89. What is the ratio of the Net Disbursements (current US$) of 2008 in Upper middle income to that in Angola?
Your response must be concise. 12.73. What is the ratio of the Net Disbursements (current US$) in 2005 in World to that in Afghanistan?
Your answer should be compact. 24.74. What is the ratio of the Net Disbursements (current US$) of 2006 in World to that in Afghanistan?
Your response must be concise. 13.54. What is the ratio of the Net Disbursements (current US$) in 2007 in World to that in Afghanistan?
Offer a very short reply. 5.74. What is the ratio of the Net Disbursements (current US$) in 2008 in World to that in Afghanistan?
Provide a succinct answer. 2.49. What is the ratio of the Net Disbursements (current US$) of 2005 in World to that in Albania?
Offer a terse response. 97. What is the ratio of the Net Disbursements (current US$) in 2006 in World to that in Albania?
Ensure brevity in your answer.  111.51. What is the ratio of the Net Disbursements (current US$) in 2007 in World to that in Albania?
Give a very brief answer. 89.57. What is the ratio of the Net Disbursements (current US$) in 2008 in World to that in Albania?
Your answer should be compact. 249.62. What is the ratio of the Net Disbursements (current US$) of 2005 in World to that in Angola?
Provide a succinct answer. 146.97. What is the ratio of the Net Disbursements (current US$) in 2006 in World to that in Angola?
Provide a succinct answer. 71.99. What is the ratio of the Net Disbursements (current US$) of 2007 in World to that in Angola?
Keep it short and to the point. 41.44. What is the ratio of the Net Disbursements (current US$) of 2008 in World to that in Angola?
Provide a succinct answer. 56.06. What is the ratio of the Net Disbursements (current US$) in 2005 in Afghanistan to that in Albania?
Provide a succinct answer. 3.92. What is the ratio of the Net Disbursements (current US$) of 2006 in Afghanistan to that in Albania?
Keep it short and to the point. 8.24. What is the ratio of the Net Disbursements (current US$) in 2007 in Afghanistan to that in Albania?
Your response must be concise. 15.62. What is the ratio of the Net Disbursements (current US$) in 2008 in Afghanistan to that in Albania?
Ensure brevity in your answer.  100.24. What is the ratio of the Net Disbursements (current US$) in 2005 in Afghanistan to that in Angola?
Provide a short and direct response. 5.94. What is the ratio of the Net Disbursements (current US$) of 2006 in Afghanistan to that in Angola?
Provide a short and direct response. 5.32. What is the ratio of the Net Disbursements (current US$) in 2007 in Afghanistan to that in Angola?
Your response must be concise. 7.22. What is the ratio of the Net Disbursements (current US$) in 2008 in Afghanistan to that in Angola?
Make the answer very short. 22.51. What is the ratio of the Net Disbursements (current US$) of 2005 in Albania to that in Angola?
Give a very brief answer. 1.52. What is the ratio of the Net Disbursements (current US$) in 2006 in Albania to that in Angola?
Ensure brevity in your answer.  0.65. What is the ratio of the Net Disbursements (current US$) in 2007 in Albania to that in Angola?
Ensure brevity in your answer.  0.46. What is the ratio of the Net Disbursements (current US$) in 2008 in Albania to that in Angola?
Your answer should be very brief. 0.22. What is the difference between the highest and the second highest Net Disbursements (current US$) of 2005?
Offer a very short reply. 2.56e+07. What is the difference between the highest and the second highest Net Disbursements (current US$) in 2006?
Offer a terse response. 2.83e+07. What is the difference between the highest and the second highest Net Disbursements (current US$) in 2007?
Your response must be concise. 3.76e+07. What is the difference between the highest and the second highest Net Disbursements (current US$) in 2008?
Provide a short and direct response. 6.27e+07. What is the difference between the highest and the lowest Net Disbursements (current US$) in 2005?
Offer a terse response. 4.82e+07. What is the difference between the highest and the lowest Net Disbursements (current US$) of 2006?
Make the answer very short. 5.64e+07. What is the difference between the highest and the lowest Net Disbursements (current US$) of 2007?
Provide a succinct answer. 6.02e+07. What is the difference between the highest and the lowest Net Disbursements (current US$) of 2008?
Provide a succinct answer. 1.04e+08. 